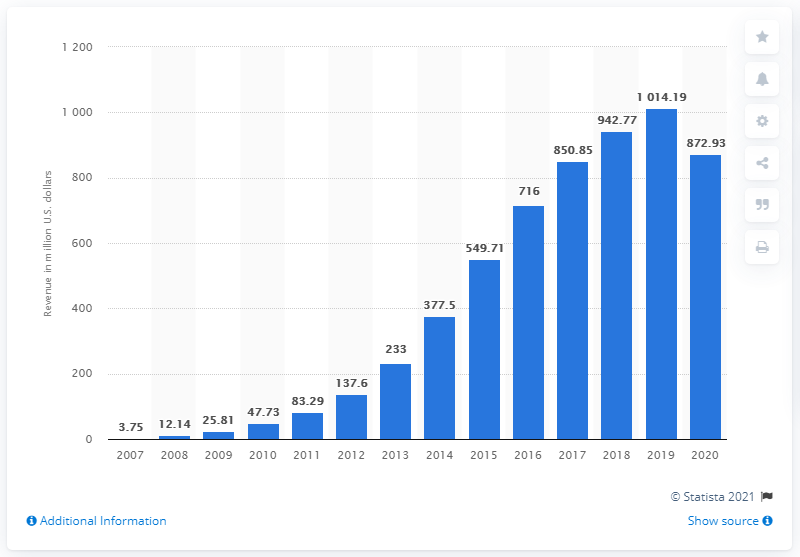Mention a couple of crucial points in this snapshot. Yelp generated revenue of approximately $1014.19 million in the previous year. In 2020, Yelp generated approximately 872.93 million in revenue. 